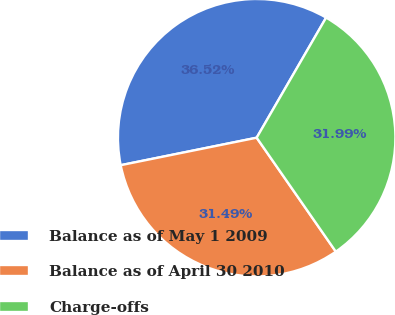<chart> <loc_0><loc_0><loc_500><loc_500><pie_chart><fcel>Balance as of May 1 2009<fcel>Balance as of April 30 2010<fcel>Charge-offs<nl><fcel>36.52%<fcel>31.49%<fcel>31.99%<nl></chart> 